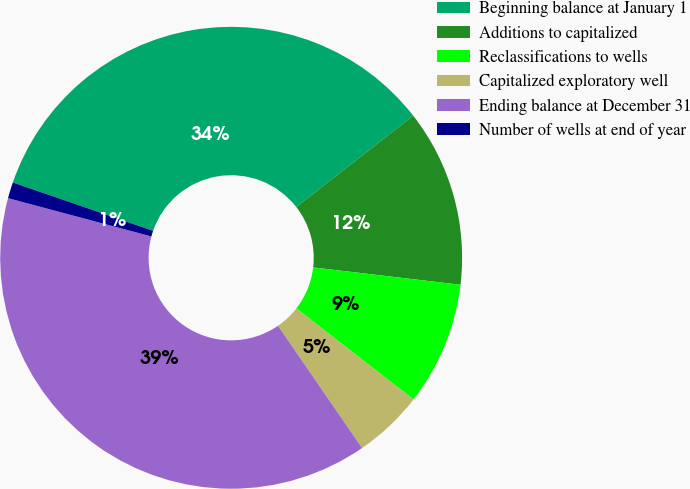<chart> <loc_0><loc_0><loc_500><loc_500><pie_chart><fcel>Beginning balance at January 1<fcel>Additions to capitalized<fcel>Reclassifications to wells<fcel>Capitalized exploratory well<fcel>Ending balance at December 31<fcel>Number of wells at end of year<nl><fcel>34.16%<fcel>12.41%<fcel>8.65%<fcel>4.89%<fcel>38.74%<fcel>1.13%<nl></chart> 